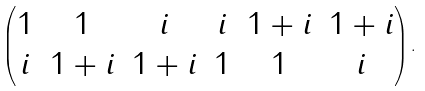Convert formula to latex. <formula><loc_0><loc_0><loc_500><loc_500>\begin{pmatrix} 1 & 1 & i & i & 1 + i & 1 + i \\ i & 1 + i & 1 + i & 1 & 1 & i \end{pmatrix} .</formula> 